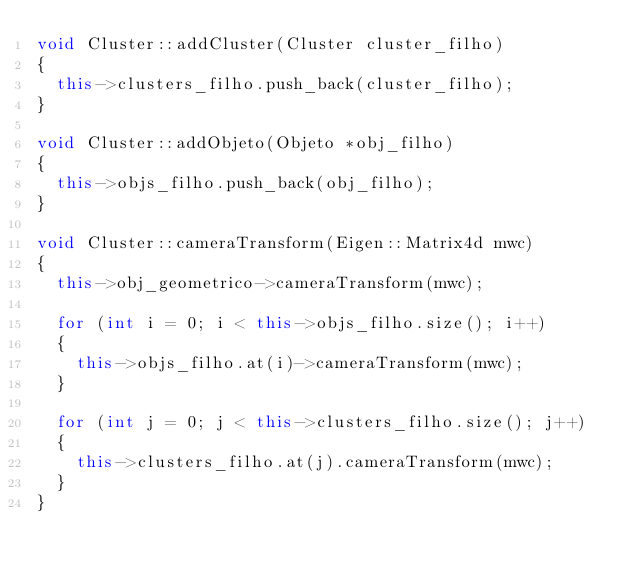Convert code to text. <code><loc_0><loc_0><loc_500><loc_500><_C++_>void Cluster::addCluster(Cluster cluster_filho)
{
  this->clusters_filho.push_back(cluster_filho);
}

void Cluster::addObjeto(Objeto *obj_filho)
{
  this->objs_filho.push_back(obj_filho);
}

void Cluster::cameraTransform(Eigen::Matrix4d mwc)
{
  this->obj_geometrico->cameraTransform(mwc);

  for (int i = 0; i < this->objs_filho.size(); i++)
  {
    this->objs_filho.at(i)->cameraTransform(mwc);
  }

  for (int j = 0; j < this->clusters_filho.size(); j++)
  {
    this->clusters_filho.at(j).cameraTransform(mwc);
  }
}</code> 